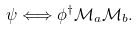Convert formula to latex. <formula><loc_0><loc_0><loc_500><loc_500>\psi \Longleftrightarrow \phi ^ { \dagger } \mathcal { M } _ { a } \mathcal { M } _ { b } .</formula> 